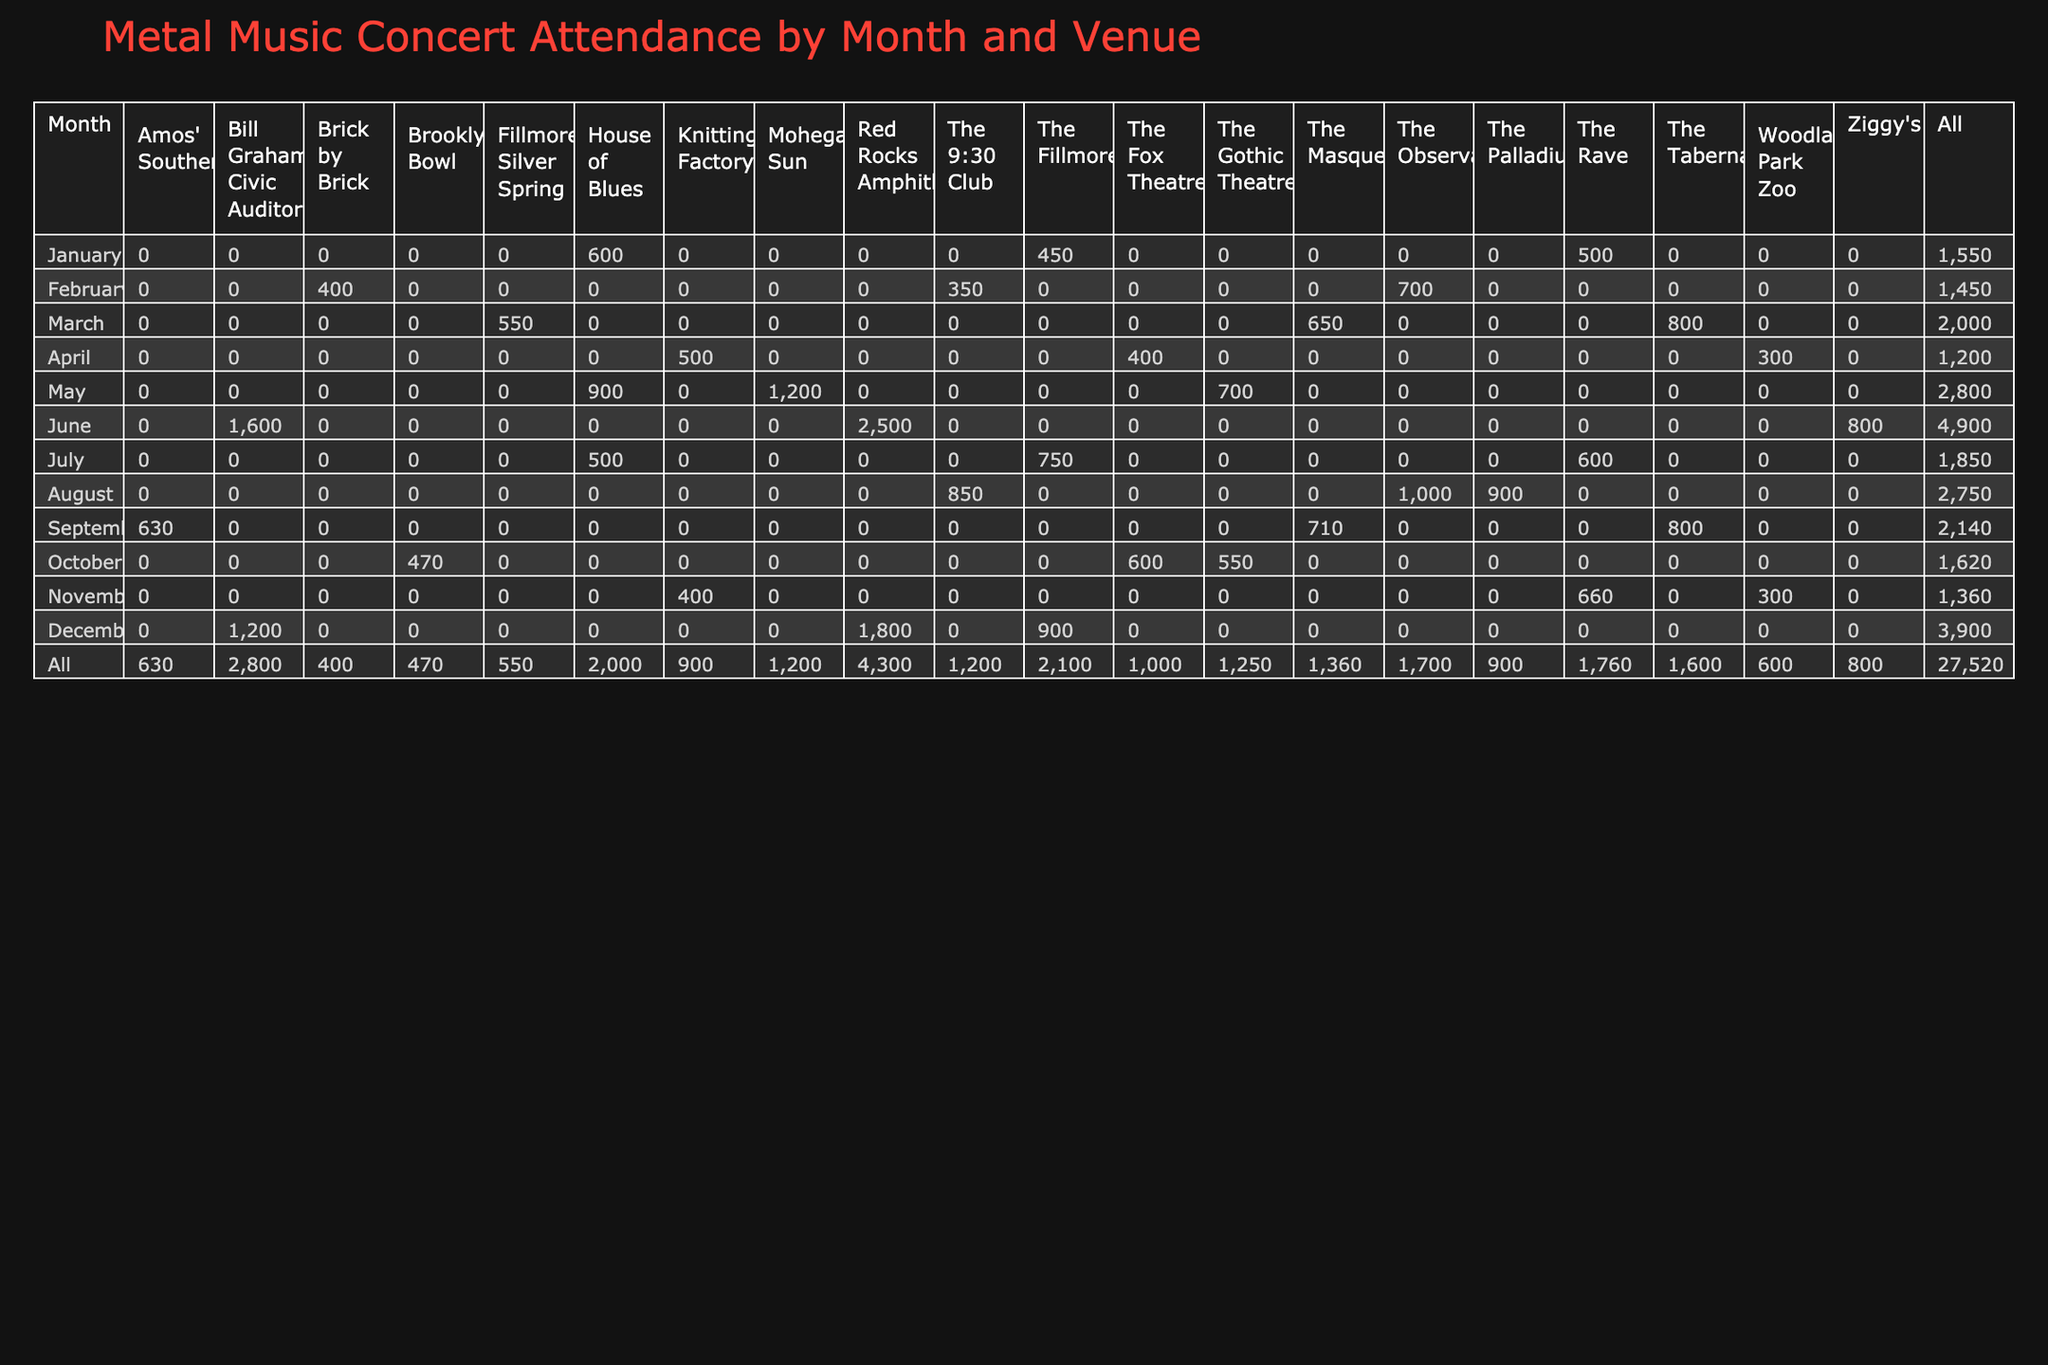What is the total attendance at the Red Rocks Amphitheatre across all months? The attendance for Red Rocks Amphitheatre can be found in the months of June (2500) and December (1800). Adding these values gives 2500 + 1800 = 4300.
Answer: 4300 Which month had the highest attendance overall? To identify the month with the highest attendance, we compare the total attendance for each month. The individual month totals are calculated as follows: 
- January: 450 + 600 + 500 = 1550
- February: 700 + 350 + 400 = 1450
- March: 800 + 550 + 650 = 2000
- April: 300 + 400 + 500 = 1200
- May: 1200 + 900 + 700 = 2800
- June: 2500 + 1600 + 800 = 4900
- July: 750 + 500 + 600 = 1850
- August: 900 + 1000 + 850 = 2750
- September: 630 + 710 + 800 = 2140
- October: 550 + 470 + 600 = 1620
- November: 660 + 300 + 400 = 1360
- December: 1800 + 1200 + 900 = 3900
The highest total observed is for June, with 4900 attendees.
Answer: June Is the attendance at The Fox Theatre in October greater than 500? The attendance at The Fox Theatre in October is recorded as 600. Since 600 is greater than 500, the statement is true.
Answer: Yes What is the average monthly attendance for the House of Blues? The House of Blues attendance records are for January (600), May (900), and July (500). To find the average, we add these values: 600 + 900 + 500 = 2000. We then divide by the number of months, which is 3. Therefore, 2000 / 3 = 666.67 (rounded to two decimal places).
Answer: 666.67 Did The Fillmore have higher attendance than The Rave in January? The attendance for The Fillmore in January is 450, whereas The Rave had 500. Since 450 is less than 500, the statement is false.
Answer: No What is the difference in total attendance between The Palladium and Ziggy's in August? In August, The Palladium had an attendance of 900, and Ziggy's had 800. To find the difference, we subtract the lower value from the higher: 900 - 800 = 100.
Answer: 100 